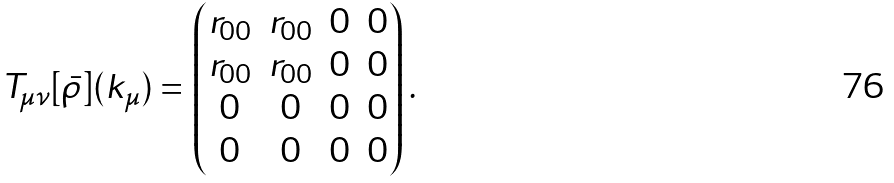Convert formula to latex. <formula><loc_0><loc_0><loc_500><loc_500>T _ { \mu \nu } [ \bar { \rho } ] ( k _ { \mu } ) = \begin{pmatrix} r _ { 0 0 } & r _ { 0 0 } & 0 & 0 \\ r _ { 0 0 } & r _ { 0 0 } & 0 & 0 \\ 0 & 0 & 0 & 0 \\ 0 & 0 & 0 & 0 \\ \end{pmatrix} .</formula> 